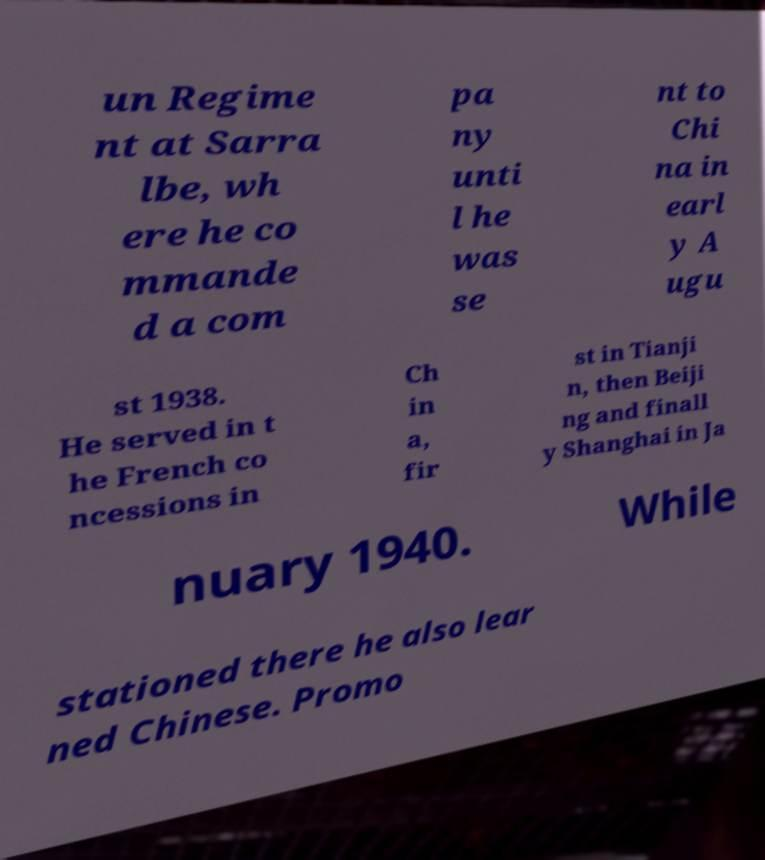I need the written content from this picture converted into text. Can you do that? un Regime nt at Sarra lbe, wh ere he co mmande d a com pa ny unti l he was se nt to Chi na in earl y A ugu st 1938. He served in t he French co ncessions in Ch in a, fir st in Tianji n, then Beiji ng and finall y Shanghai in Ja nuary 1940. While stationed there he also lear ned Chinese. Promo 